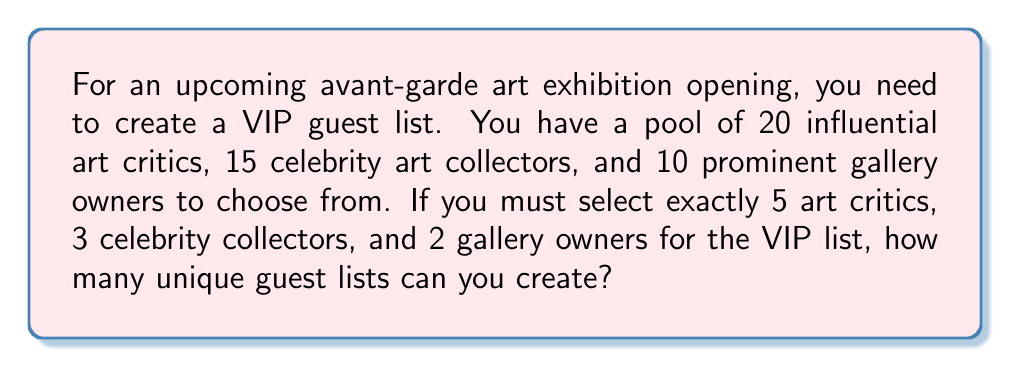Can you solve this math problem? Let's break this down step-by-step:

1) We need to select:
   - 5 art critics out of 20
   - 3 celebrity collectors out of 15
   - 2 gallery owners out of 10

2) For each category, we're selecting a subset without regard to order, so we'll use combinations.

3) For art critics:
   We're choosing 5 out of 20, which is denoted as $\binom{20}{5}$
   $$\binom{20}{5} = \frac{20!}{5!(20-5)!} = \frac{20!}{5!15!} = 15,504$$

4) For celebrity collectors:
   We're choosing 3 out of 15, which is $\binom{15}{3}$
   $$\binom{15}{3} = \frac{15!}{3!(15-3)!} = \frac{15!}{3!12!} = 455$$

5) For gallery owners:
   We're choosing 2 out of 10, which is $\binom{10}{2}$
   $$\binom{10}{2} = \frac{10!}{2!(10-2)!} = \frac{10!}{2!8!} = 45$$

6) Now, by the Multiplication Principle, since each choice is independent, we multiply these numbers together to get the total number of possible unique guest lists:

   $$15,504 \times 455 \times 45 = 317,068,200$$

Thus, there are 317,068,200 unique VIP guest lists possible.
Answer: 317,068,200 